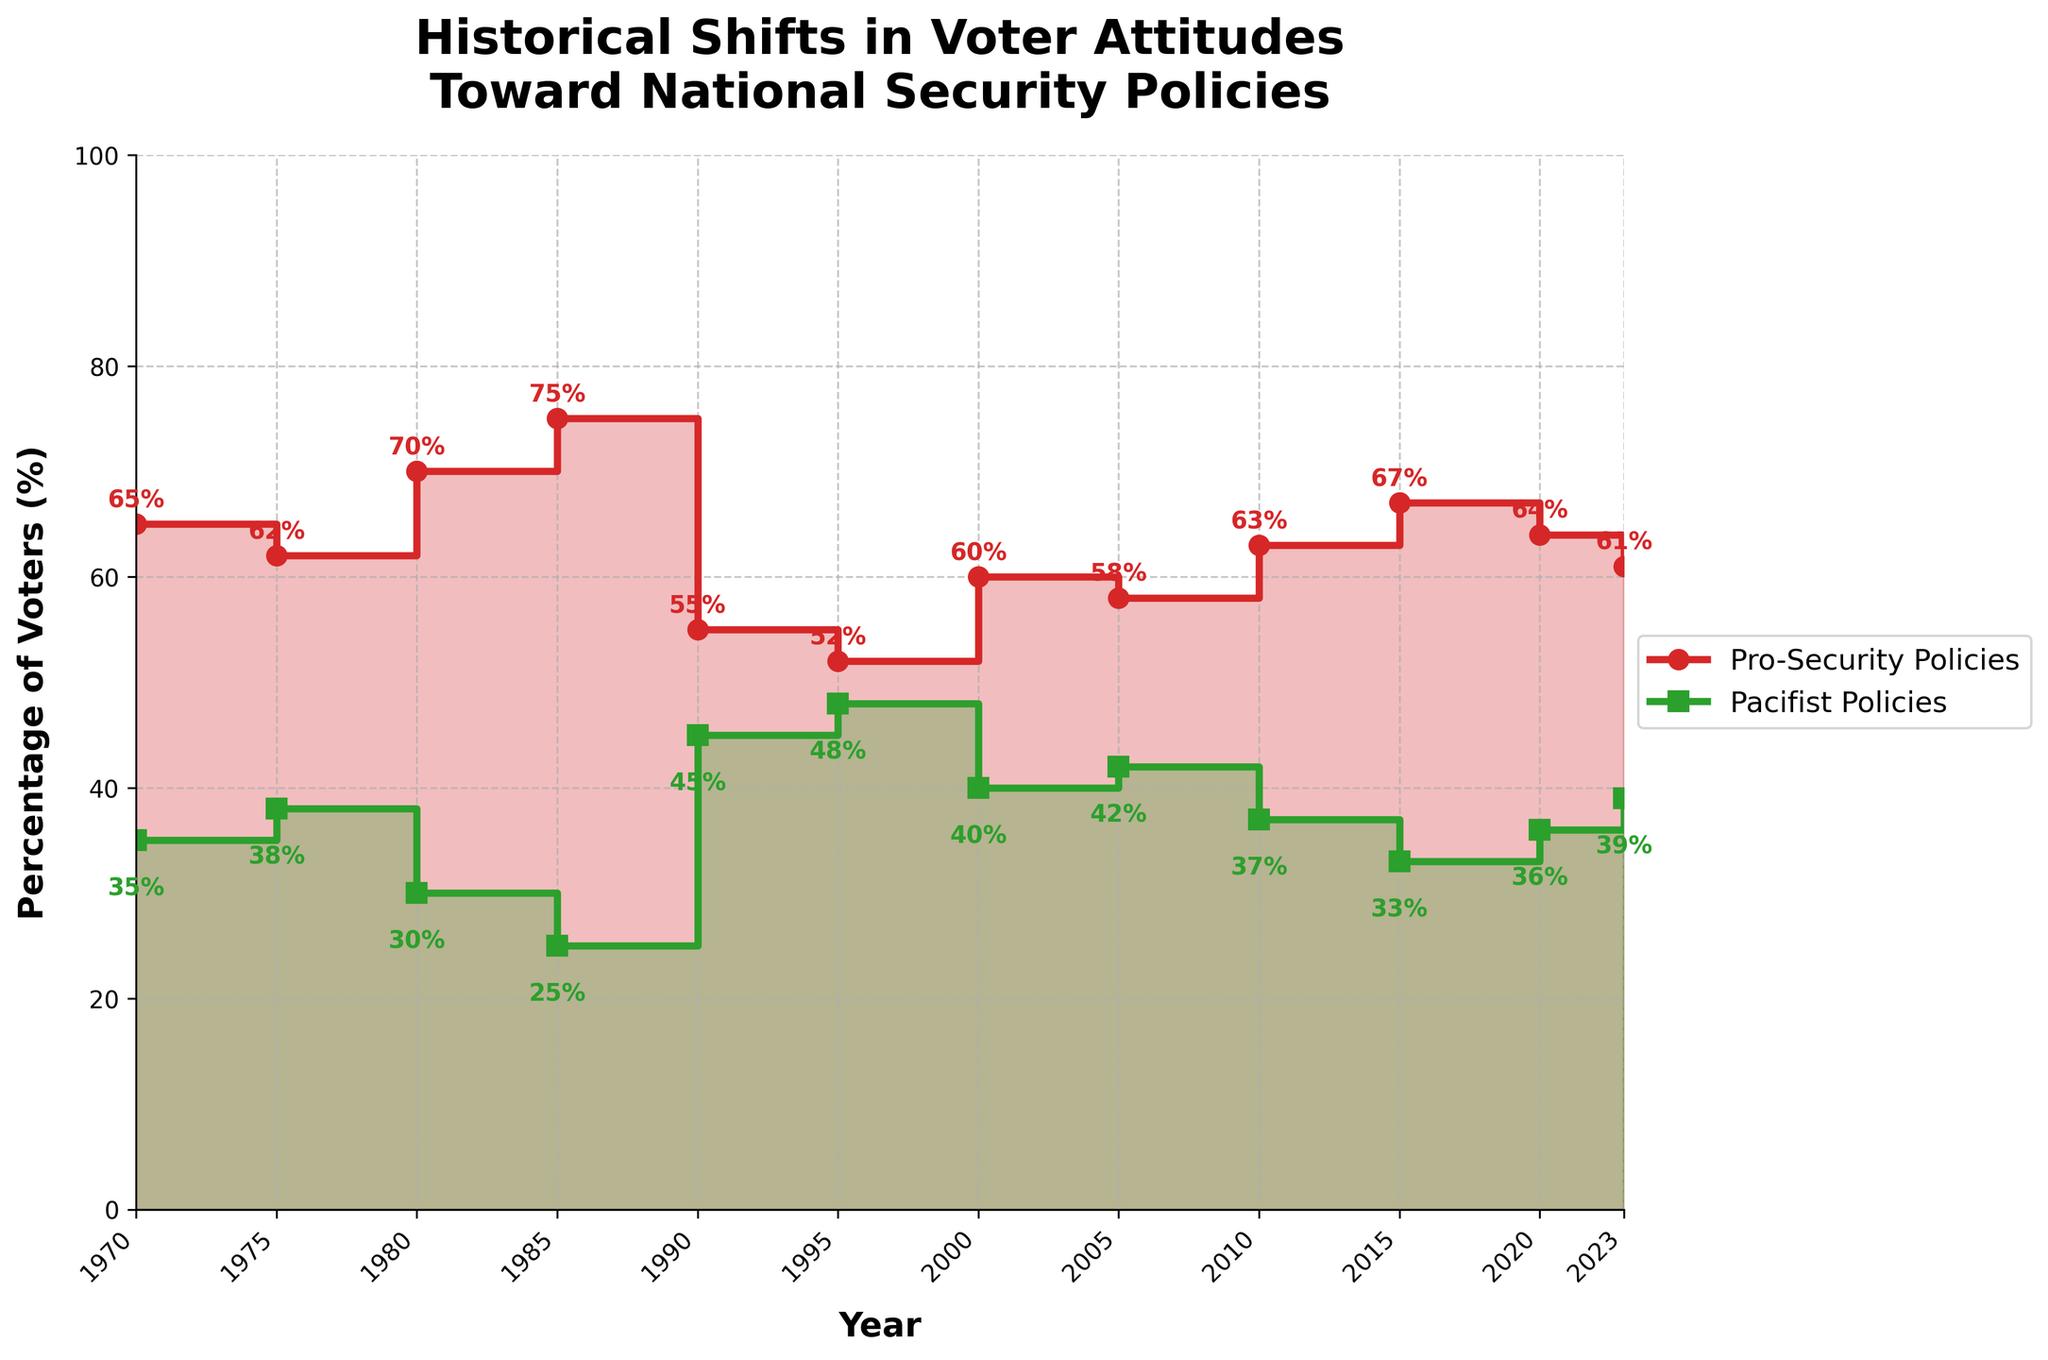What's the title of the figure? The title is located at the top of the chart and usually provides a summary of what the figure represents. By looking at the figure, the title reads "Historical Shifts in Voter Attitudes Toward National Security Policies".
Answer: Historical Shifts in Voter Attitudes Toward National Security Policies What is the percentage of voters supporting Pro-Security Policies in 1980? To find this, look at the year 1980 on the x-axis and then follow the stair step up to the Pro-Security Policies line. The value at that point is labeled directly on the plot.
Answer: 70% By how much did the percentage of voters for Pacifist Policies increase from 1985 to 1990? First, identify the percentage for Pacifist Policies in 1985 and 1990 by looking at the plot. In 1985, it is 25%, and in 1990, it is 45%. Subtract the 1985 percentage from the 1990 percentage (45% - 25%).
Answer: 20% Which year had the largest gap between Pro-Security Policies and Pacifist Policies? To determine this, examine the differences between the two series for each year and identify the year with the maximum difference. The largest gap is in 1985, with Pro-Security at 75% and Pacifist at 25%, thus a gap of 50%.
Answer: 1985 How many years show that at least 60% of voters supported Pro-Security Policies? Count the years where the percentage value for Pro-Security Policies is equal to or exceeds 60%. These years are 1970, 1980, 1985, 2000, 2010, and 2015.
Answer: 6 years Which year marks a notable dip in support for Pro-Security Policies compared to previous years? Identify a significant drop in support levels by comparing each year's percentage to the previous one. The notable dip occurs in 1990, where the support for Pro-Security Policies drops sharply from 75% in 1985 to 55%.
Answer: 1990 What is the trend for Pacifist Policies from 1995 to 2005? Check the stair plot section from 1995 to 2005. The percentages go from 48% in 1995 to 42% in 2005, showing a decreasing trend.
Answer: Decreasing How did voter attitudes toward Pro-Security Policies change from 2015 to 2023? Examine the percentages for Pro-Security Policies in 2015, 2020, and 2023. They are 67%, 64%, and 61%, respectively, indicating a decreasing trend.
Answer: Decreased What is the average percentage of Pro-Security Policies across the given years? Sum all the Pro-Security percentages (65 + 62 + 70 + 75 + 55 + 52 + 60 + 58 + 63 + 67 + 64 + 61) and then divide by the number of years (12). The calculation is (752/12).
Answer: 62.67% In which years did the proportions of Pro-Security and Pacifist Policies voters add up to exactly 100%? All the given years sum up to 100% because the only categories displayed are Pro-Security and Pacifist Policies, representing binary choices so their complements add up to 100%. Check the entire data set to confirm this.
Answer: All years 